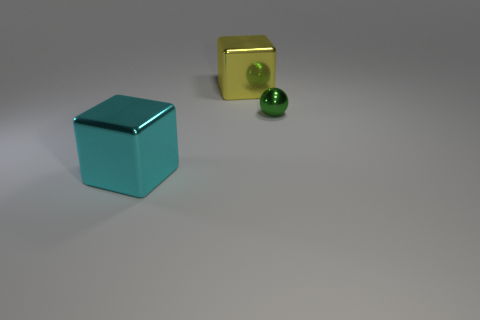What is the color of the metal block that is to the left of the big object behind the tiny shiny thing?
Your answer should be compact. Cyan. There is a shiny thing behind the tiny sphere; does it have the same color as the tiny ball?
Give a very brief answer. No. Does the yellow block have the same size as the green shiny thing?
Your answer should be very brief. No. There is a shiny object that is the same size as the yellow cube; what shape is it?
Ensure brevity in your answer.  Cube. There is a metallic block behind the cyan metal object; does it have the same size as the tiny green thing?
Offer a very short reply. No. What is the material of the cyan thing that is the same size as the yellow object?
Your response must be concise. Metal. There is a metallic cube behind the big metallic object that is in front of the tiny green ball; are there any small green spheres behind it?
Keep it short and to the point. No. Are there any other things that have the same shape as the tiny thing?
Offer a very short reply. No. There is a metal thing behind the metal ball; does it have the same color as the block that is in front of the tiny thing?
Your answer should be very brief. No. Are any small red metal cubes visible?
Your response must be concise. No. 